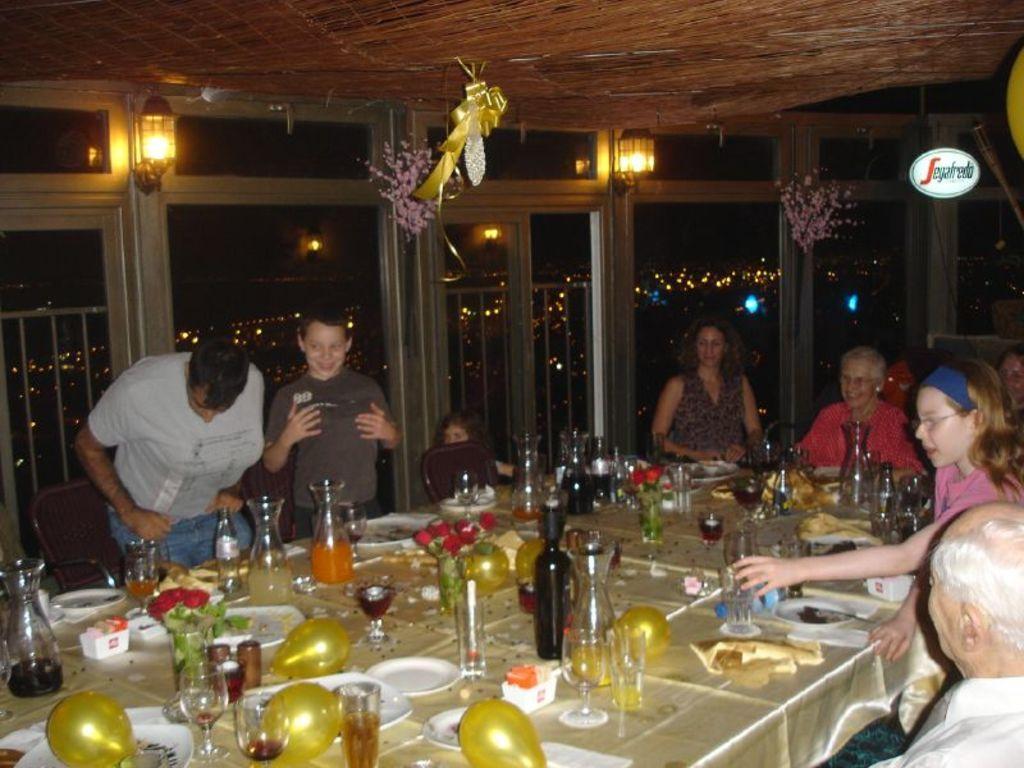Describe this image in one or two sentences. In this image we can see this people sitting near the table and this people are standing near the table. We can see plates, glasses, jars, bottles, flower vases, balloons and few things on the table. In the background we can see glass windows and lights. 